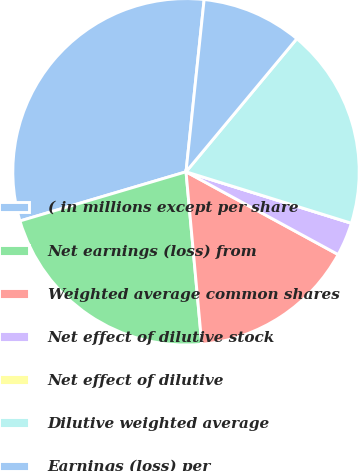Convert chart to OTSL. <chart><loc_0><loc_0><loc_500><loc_500><pie_chart><fcel>( in millions except per share<fcel>Net earnings (loss) from<fcel>Weighted average common shares<fcel>Net effect of dilutive stock<fcel>Net effect of dilutive<fcel>Dilutive weighted average<fcel>Earnings (loss) per<nl><fcel>31.25%<fcel>21.87%<fcel>15.62%<fcel>3.13%<fcel>0.0%<fcel>18.75%<fcel>9.38%<nl></chart> 